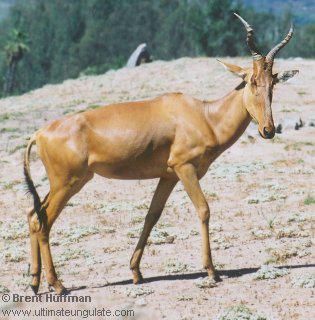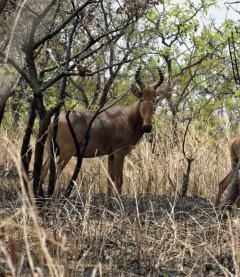The first image is the image on the left, the second image is the image on the right. Analyze the images presented: Is the assertion "One of the animals is standing in left profile." valid? Answer yes or no. No. The first image is the image on the left, the second image is the image on the right. For the images displayed, is the sentence "Each image contains just one horned animal, and the animals' faces and bodies are turned in different directions." factually correct? Answer yes or no. No. 